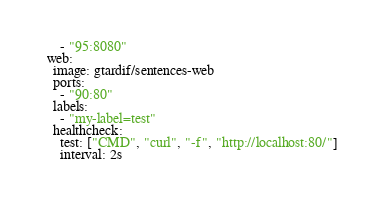Convert code to text. <code><loc_0><loc_0><loc_500><loc_500><_YAML_>      - "95:8080"
  web:
    image: gtardif/sentences-web
    ports:
      - "90:80"
    labels:
      - "my-label=test"
    healthcheck:
      test: ["CMD", "curl", "-f", "http://localhost:80/"]
      interval: 2s
</code> 